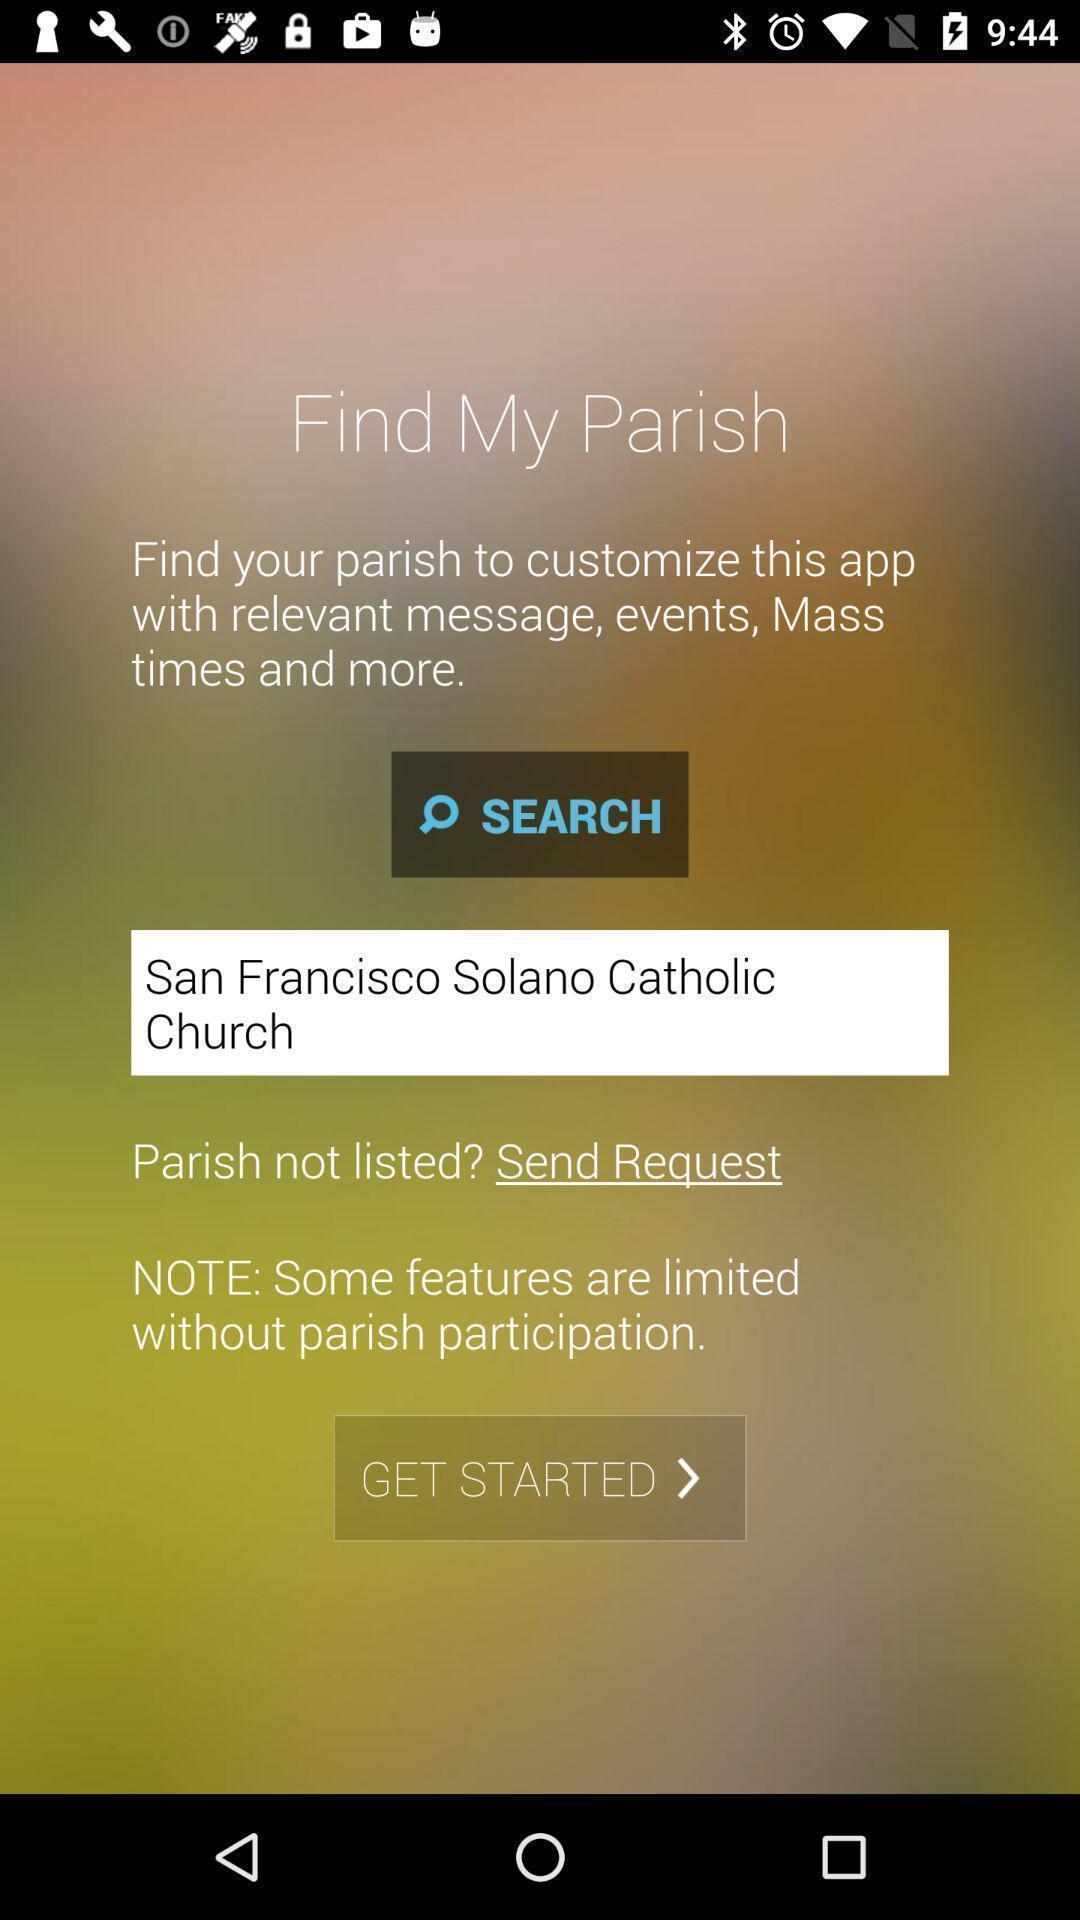What is the overall content of this screenshot? Search to search for location in app. 